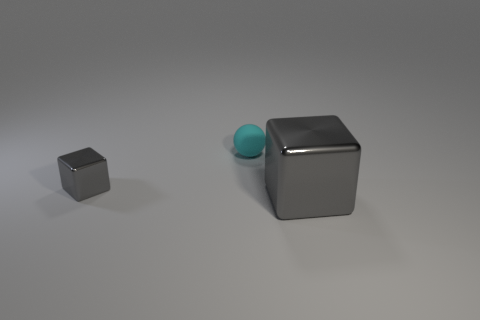Add 1 small metal things. How many objects exist? 4 Subtract all blocks. How many objects are left? 1 Add 1 large gray metallic things. How many large gray metallic things exist? 2 Subtract 0 brown balls. How many objects are left? 3 Subtract all large green cylinders. Subtract all small cyan rubber things. How many objects are left? 2 Add 1 big metallic cubes. How many big metallic cubes are left? 2 